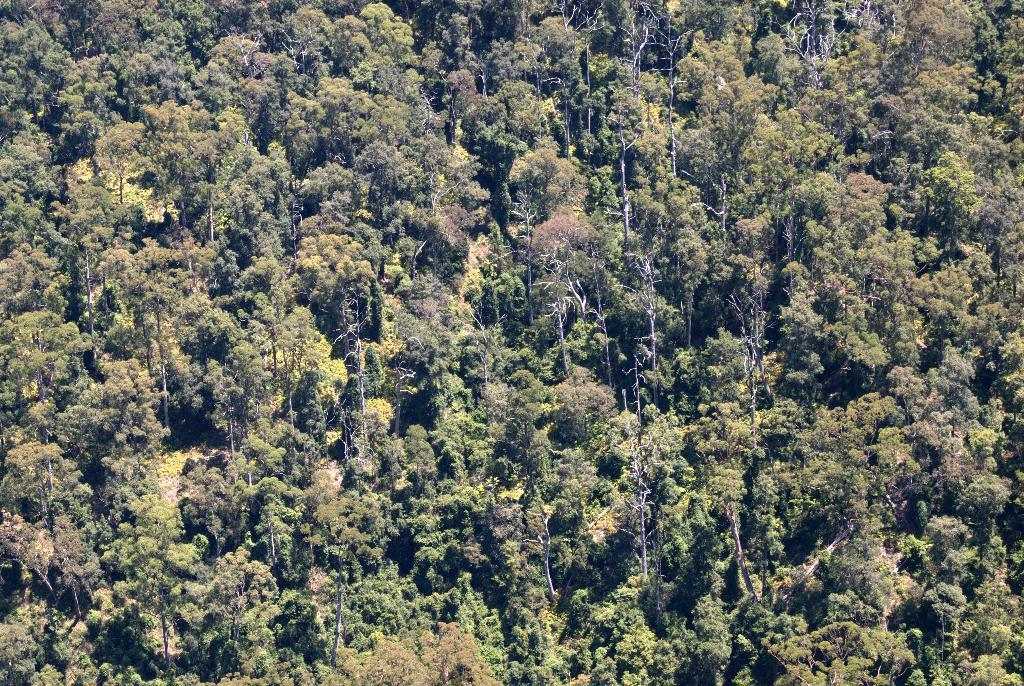What type of vegetation can be seen in the image? There are trees in the image. Is there a spy hiding behind the trees in the image? There is no indication of a spy or any hidden figures in the image; it only features trees. 